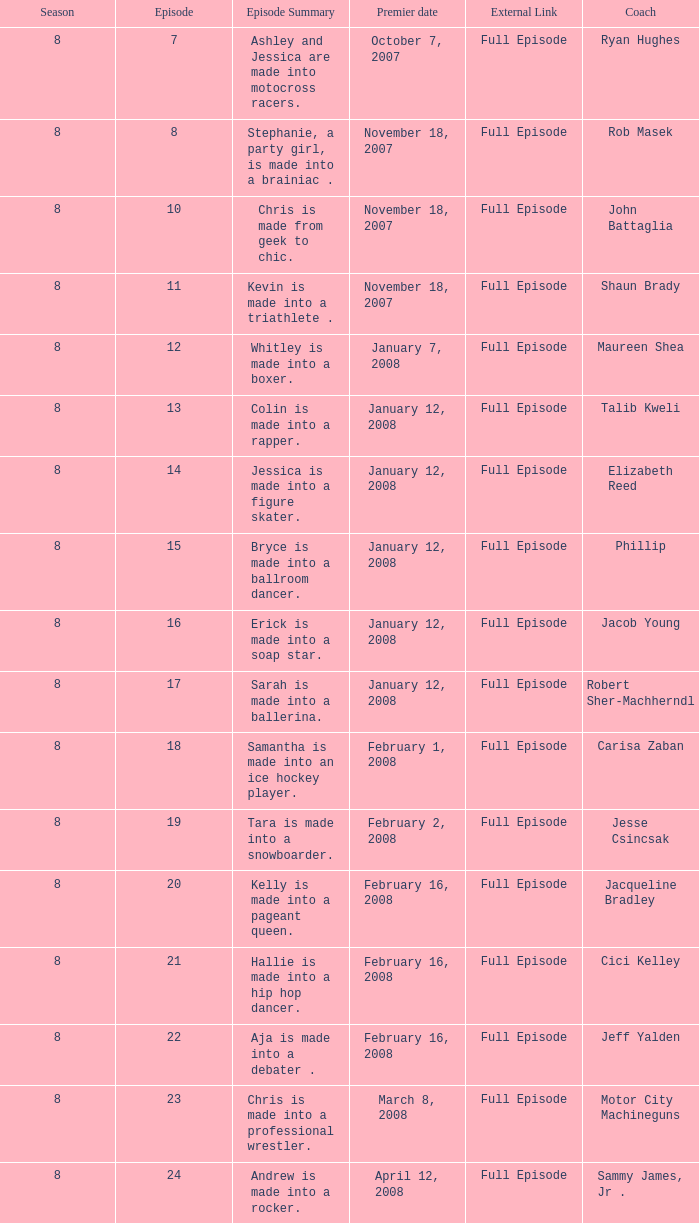How many seasons include rob masek? 1.0. 